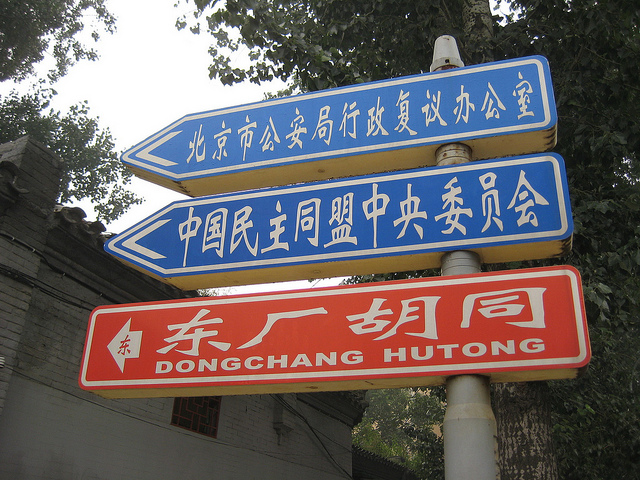<image>What does the sign say? I am not sure what the sign says. It could possibly say 'dongchang hutong'. What does the sign say? The sign says "dongchang hutong". 